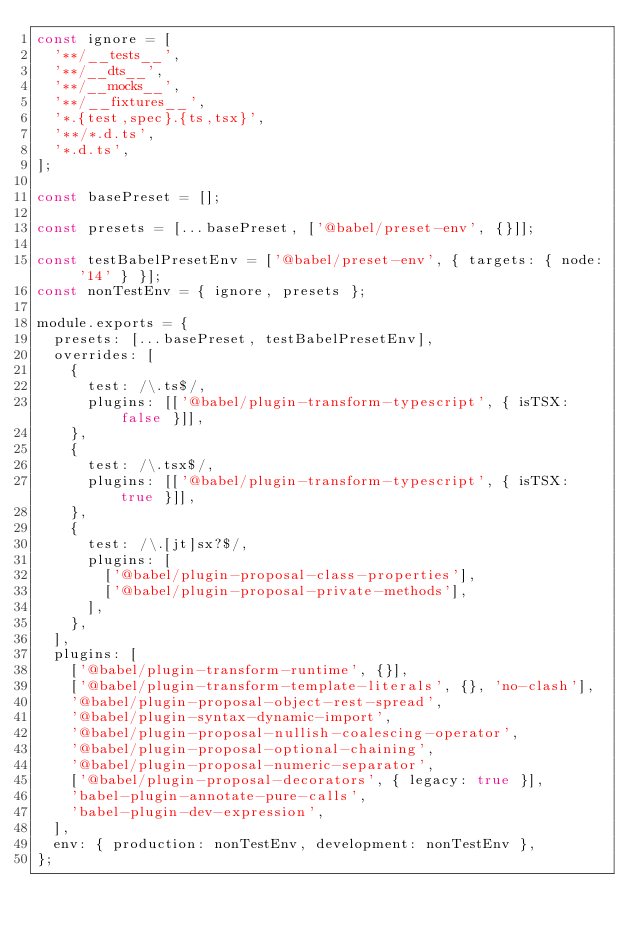<code> <loc_0><loc_0><loc_500><loc_500><_JavaScript_>const ignore = [
  '**/__tests__',
  '**/__dts__',
  '**/__mocks__',
  '**/__fixtures__',
  '*.{test,spec}.{ts,tsx}',
  '**/*.d.ts',
  '*.d.ts',
];

const basePreset = [];

const presets = [...basePreset, ['@babel/preset-env', {}]];

const testBabelPresetEnv = ['@babel/preset-env', { targets: { node: '14' } }];
const nonTestEnv = { ignore, presets };

module.exports = {
  presets: [...basePreset, testBabelPresetEnv],
  overrides: [
    {
      test: /\.ts$/,
      plugins: [['@babel/plugin-transform-typescript', { isTSX: false }]],
    },
    {
      test: /\.tsx$/,
      plugins: [['@babel/plugin-transform-typescript', { isTSX: true }]],
    },
    {
      test: /\.[jt]sx?$/,
      plugins: [
        ['@babel/plugin-proposal-class-properties'],
        ['@babel/plugin-proposal-private-methods'],
      ],
    },
  ],
  plugins: [
    ['@babel/plugin-transform-runtime', {}],
    ['@babel/plugin-transform-template-literals', {}, 'no-clash'],
    '@babel/plugin-proposal-object-rest-spread',
    '@babel/plugin-syntax-dynamic-import',
    '@babel/plugin-proposal-nullish-coalescing-operator',
    '@babel/plugin-proposal-optional-chaining',
    '@babel/plugin-proposal-numeric-separator',
    ['@babel/plugin-proposal-decorators', { legacy: true }],
    'babel-plugin-annotate-pure-calls',
    'babel-plugin-dev-expression',
  ],
  env: { production: nonTestEnv, development: nonTestEnv },
};
</code> 